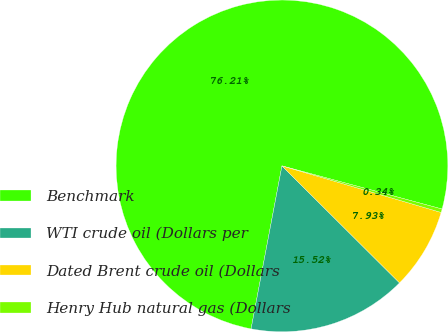Convert chart. <chart><loc_0><loc_0><loc_500><loc_500><pie_chart><fcel>Benchmark<fcel>WTI crude oil (Dollars per<fcel>Dated Brent crude oil (Dollars<fcel>Henry Hub natural gas (Dollars<nl><fcel>76.21%<fcel>15.52%<fcel>7.93%<fcel>0.34%<nl></chart> 